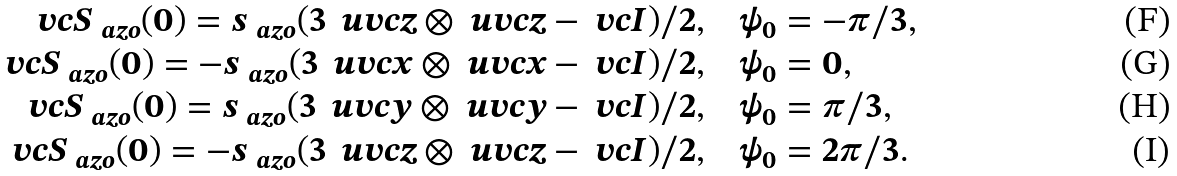<formula> <loc_0><loc_0><loc_500><loc_500>\ v c { S } _ { \ a z o } ( 0 ) = s _ { \ a z o } ( 3 \, \ u v c { z } \otimes \ u v c { z } - \ v c { I } ) / 2 , & \quad \psi _ { 0 } = - \pi / 3 , \\ \ v c { S } _ { \ a z o } ( 0 ) = - s _ { \ a z o } ( 3 \, \ u v c { x } \otimes \ u v c { x } - \ v c { I } ) / 2 , & \quad \psi _ { 0 } = 0 , \\ \ v c { S } _ { \ a z o } ( 0 ) = s _ { \ a z o } ( 3 \, \ u v c { y } \otimes \ u v c { y } - \ v c { I } ) / 2 , & \quad \psi _ { 0 } = \pi / 3 , \\ \ v c { S } _ { \ a z o } ( 0 ) = - s _ { \ a z o } ( 3 \, \ u v c { z } \otimes \ u v c { z } - \ v c { I } ) / 2 , & \quad \psi _ { 0 } = 2 \pi / 3 .</formula> 